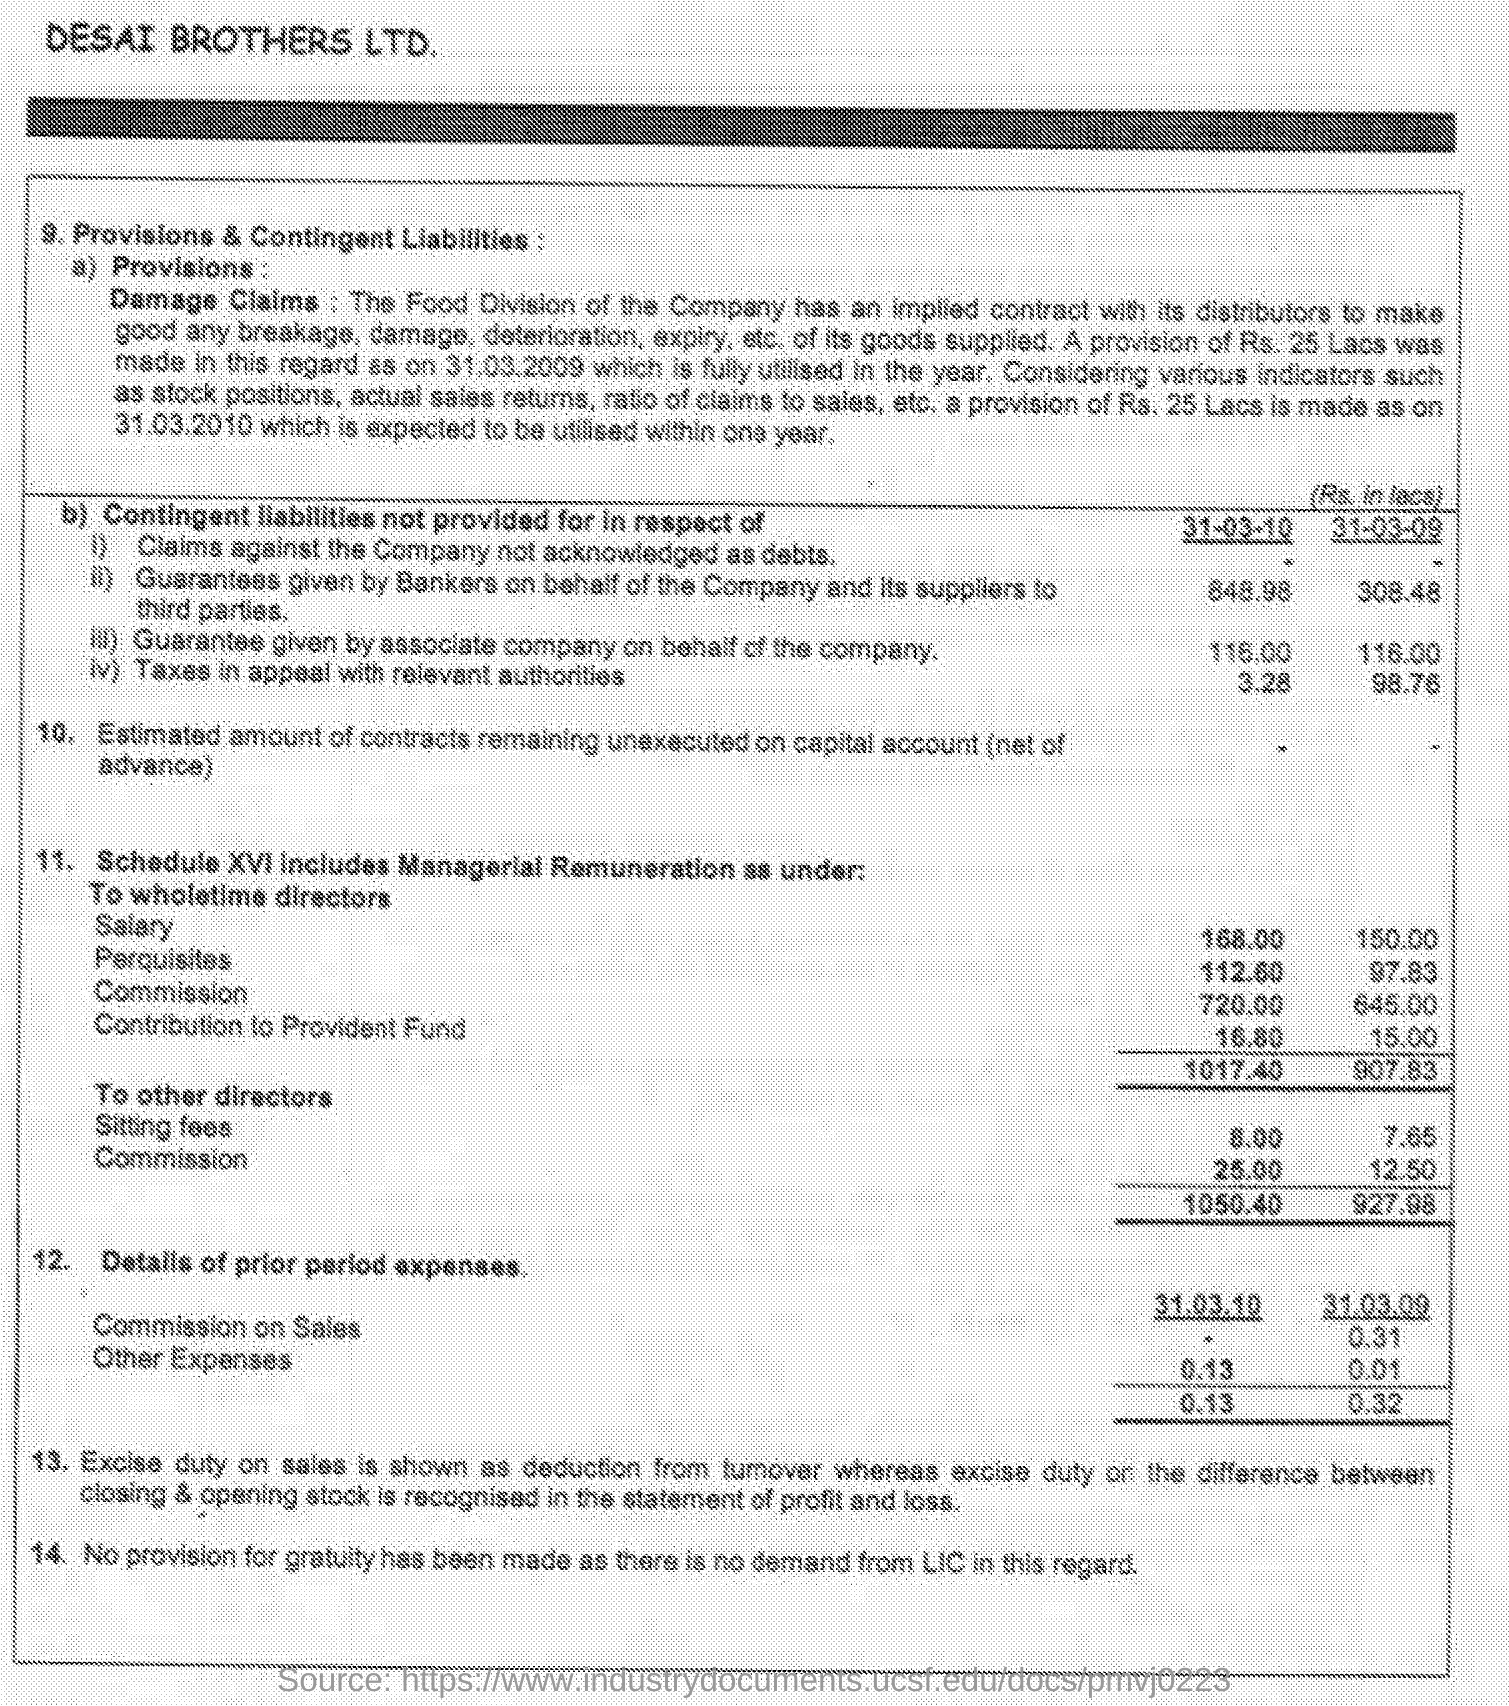What is the Sitting fees for 31-03-10?
Your response must be concise. 8.00. What is the Sitting fees for 31-03-09?
Provide a short and direct response. 7.65. What is the Perquisites for 31-03-10?
Offer a terse response. 112.60. What is the Perquisites for 31-03-09?
Your answer should be very brief. 97.83. 